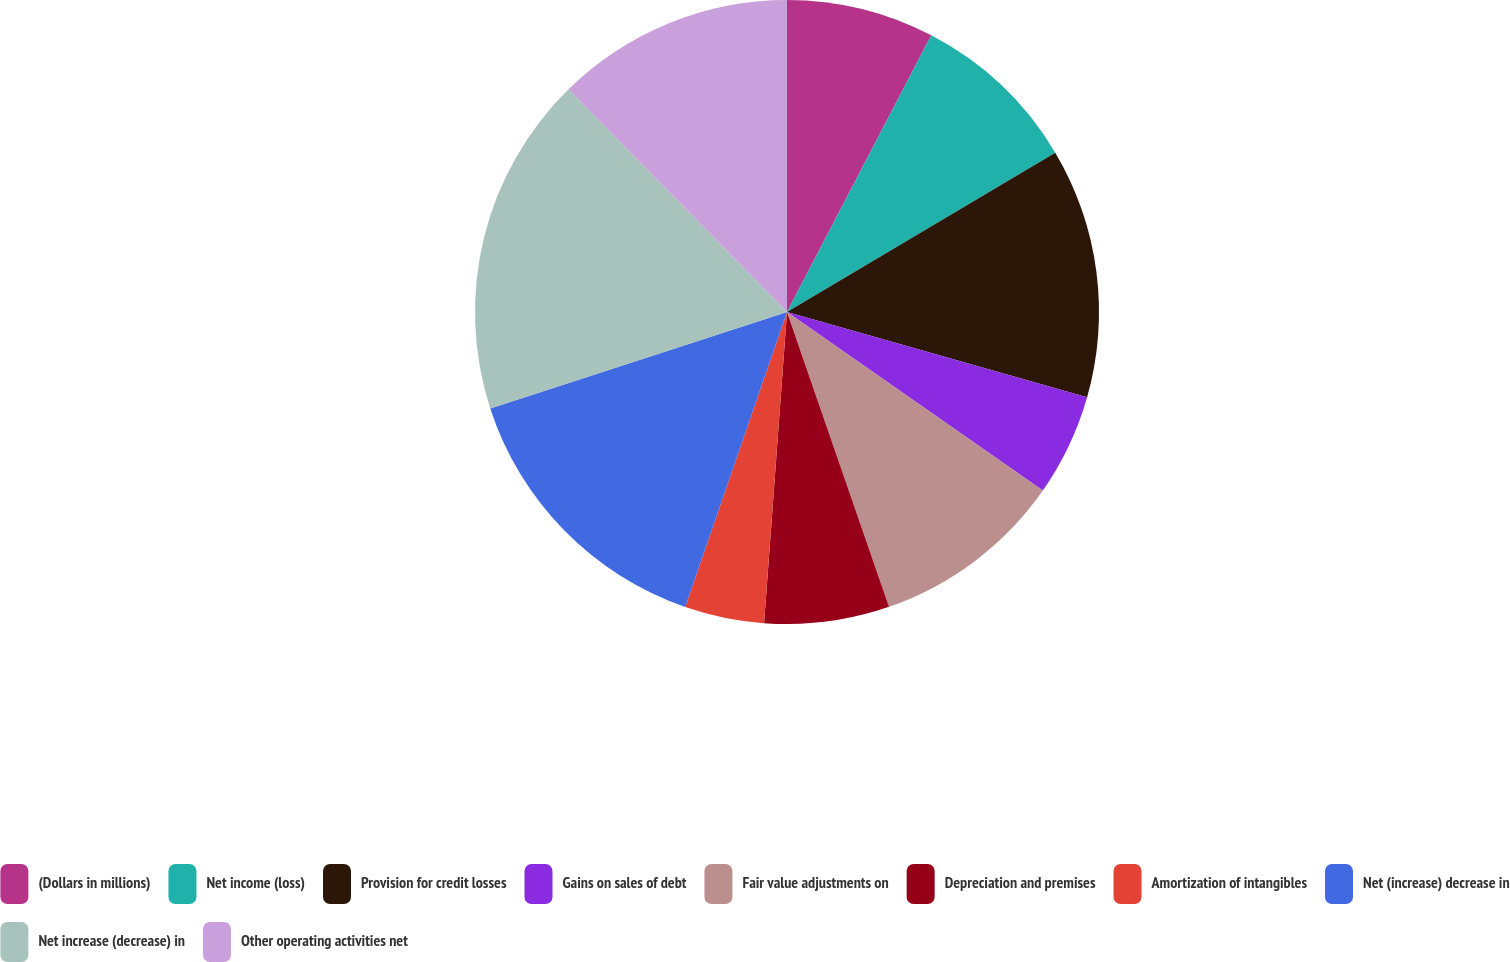<chart> <loc_0><loc_0><loc_500><loc_500><pie_chart><fcel>(Dollars in millions)<fcel>Net income (loss)<fcel>Provision for credit losses<fcel>Gains on sales of debt<fcel>Fair value adjustments on<fcel>Depreciation and premises<fcel>Amortization of intangibles<fcel>Net (increase) decrease in<fcel>Net increase (decrease) in<fcel>Other operating activities net<nl><fcel>7.65%<fcel>8.82%<fcel>12.94%<fcel>5.29%<fcel>10.0%<fcel>6.47%<fcel>4.12%<fcel>14.71%<fcel>17.65%<fcel>12.35%<nl></chart> 